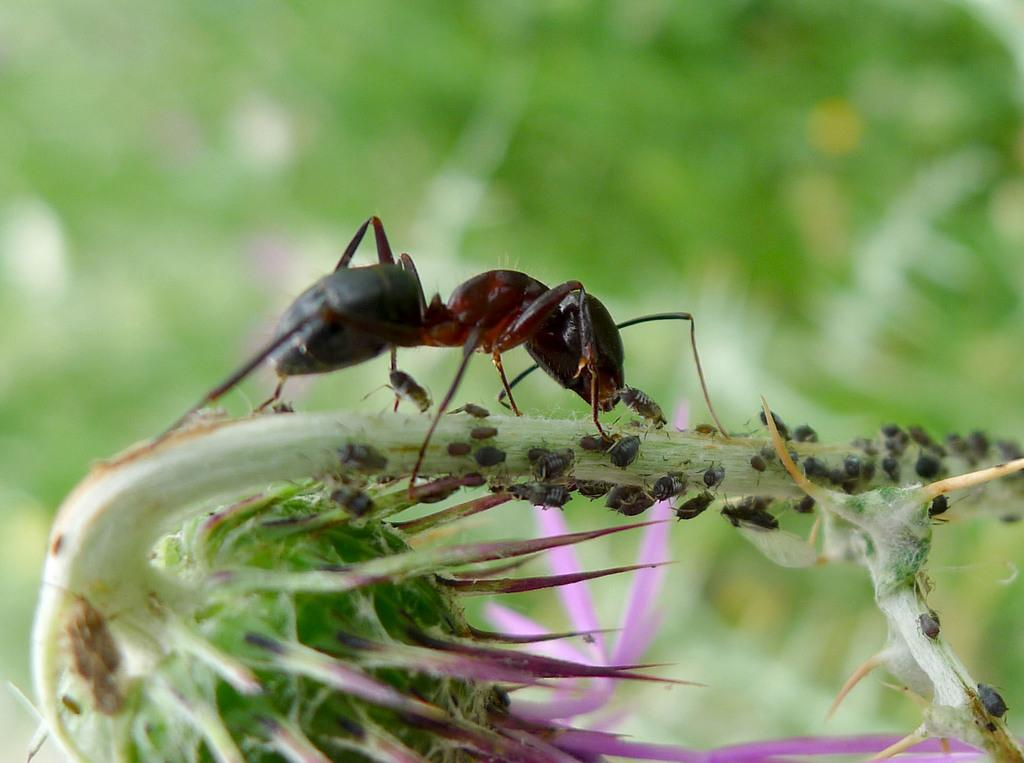What type of creature can be seen in the image? There is an ant in the image. What else can be seen in the image besides the ant? There are other insects in the image. Where are the insects located in the image? The insects are on a plant. What is the plant's feature in the image? The plant has a flower. How would you describe the background of the image? The background of the image is blurred and appears to be greenery. What type of lettuce is being sorted in the image? There is no lettuce or sorting activity present in the image. 